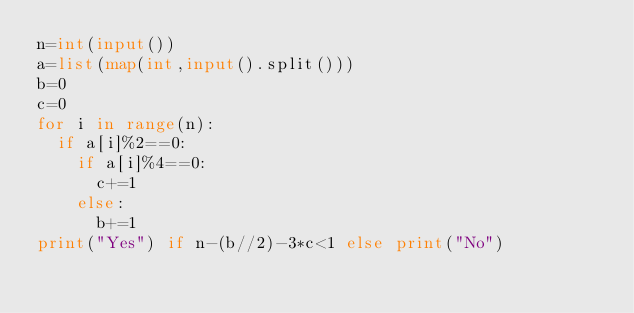<code> <loc_0><loc_0><loc_500><loc_500><_Python_>n=int(input())
a=list(map(int,input().split()))
b=0
c=0
for i in range(n):
  if a[i]%2==0:
    if a[i]%4==0:
      c+=1
    else:
      b+=1
print("Yes") if n-(b//2)-3*c<1 else print("No")
</code> 